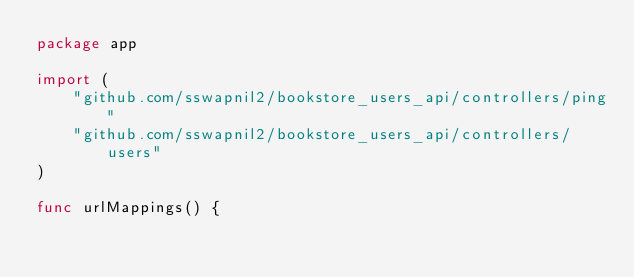Convert code to text. <code><loc_0><loc_0><loc_500><loc_500><_Go_>package app

import (
	"github.com/sswapnil2/bookstore_users_api/controllers/ping"
	"github.com/sswapnil2/bookstore_users_api/controllers/users"
)

func urlMappings() {</code> 